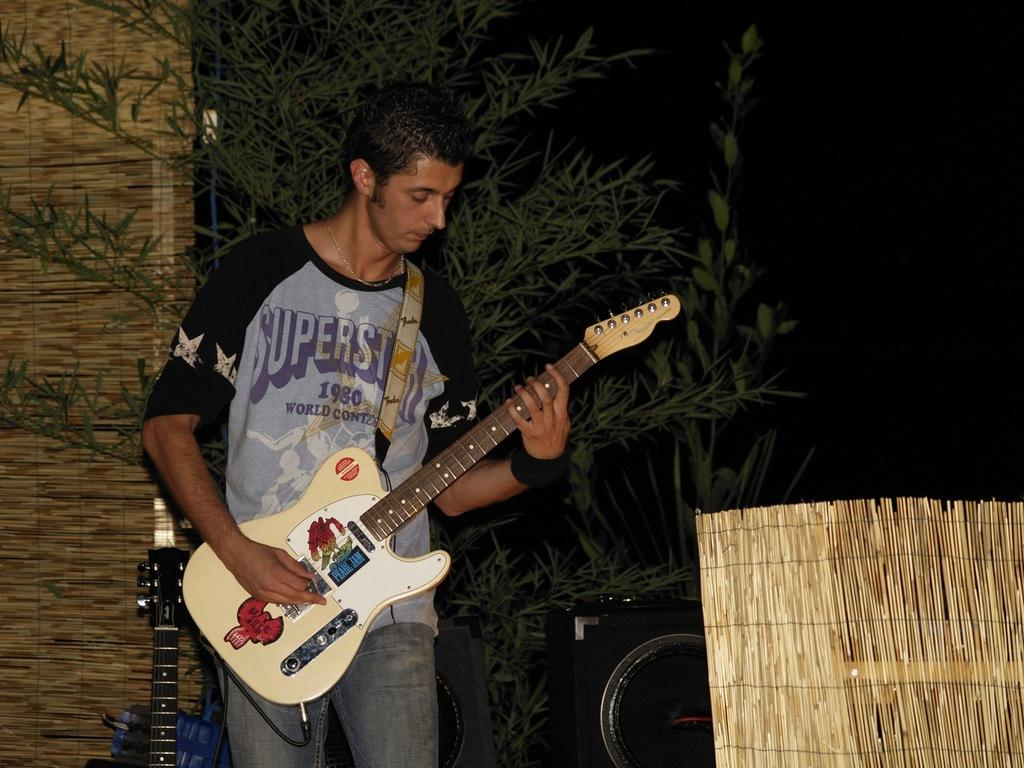What is the person in the image doing? The person is holding a guitar. What objects are present on the right side of the image? There are speakers on the right side of the image. What can be seen in the background of the image? There is a tree in the background of the image. What type of base is supporting the guitar in the image? There is no base supporting the guitar in the image; the person is holding it. What color are the trousers the person is wearing in the image? The provided facts do not mention the color of the person's trousers, so we cannot determine that information from the image. 